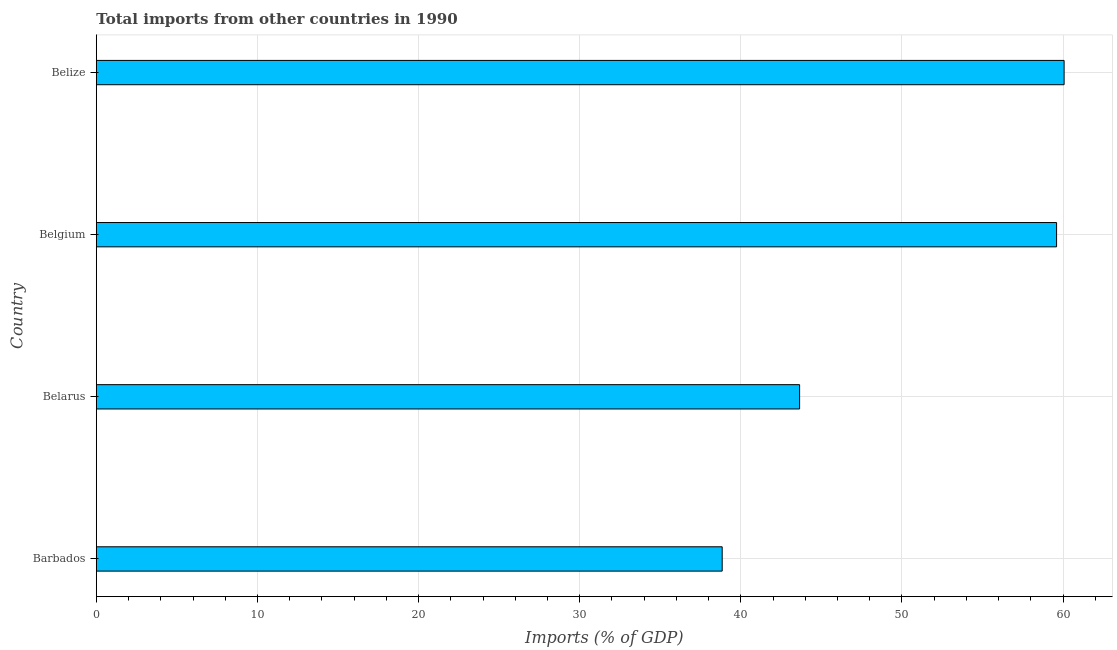Does the graph contain grids?
Give a very brief answer. Yes. What is the title of the graph?
Offer a very short reply. Total imports from other countries in 1990. What is the label or title of the X-axis?
Offer a terse response. Imports (% of GDP). What is the label or title of the Y-axis?
Keep it short and to the point. Country. What is the total imports in Belize?
Give a very brief answer. 60.07. Across all countries, what is the maximum total imports?
Offer a very short reply. 60.07. Across all countries, what is the minimum total imports?
Your answer should be very brief. 38.84. In which country was the total imports maximum?
Provide a succinct answer. Belize. In which country was the total imports minimum?
Make the answer very short. Barbados. What is the sum of the total imports?
Offer a very short reply. 202.16. What is the difference between the total imports in Barbados and Belize?
Give a very brief answer. -21.22. What is the average total imports per country?
Make the answer very short. 50.54. What is the median total imports?
Offer a terse response. 51.62. In how many countries, is the total imports greater than 56 %?
Provide a succinct answer. 2. What is the ratio of the total imports in Belarus to that in Belgium?
Offer a very short reply. 0.73. Is the total imports in Belgium less than that in Belize?
Provide a succinct answer. Yes. Is the difference between the total imports in Barbados and Belarus greater than the difference between any two countries?
Provide a succinct answer. No. What is the difference between the highest and the second highest total imports?
Make the answer very short. 0.47. What is the difference between the highest and the lowest total imports?
Keep it short and to the point. 21.22. In how many countries, is the total imports greater than the average total imports taken over all countries?
Your answer should be compact. 2. How many bars are there?
Keep it short and to the point. 4. Are all the bars in the graph horizontal?
Your response must be concise. Yes. How many countries are there in the graph?
Your answer should be very brief. 4. Are the values on the major ticks of X-axis written in scientific E-notation?
Your answer should be very brief. No. What is the Imports (% of GDP) in Barbados?
Provide a short and direct response. 38.84. What is the Imports (% of GDP) of Belarus?
Your response must be concise. 43.65. What is the Imports (% of GDP) in Belgium?
Your answer should be very brief. 59.6. What is the Imports (% of GDP) of Belize?
Keep it short and to the point. 60.07. What is the difference between the Imports (% of GDP) in Barbados and Belarus?
Offer a terse response. -4.81. What is the difference between the Imports (% of GDP) in Barbados and Belgium?
Keep it short and to the point. -20.75. What is the difference between the Imports (% of GDP) in Barbados and Belize?
Keep it short and to the point. -21.22. What is the difference between the Imports (% of GDP) in Belarus and Belgium?
Provide a short and direct response. -15.95. What is the difference between the Imports (% of GDP) in Belarus and Belize?
Offer a terse response. -16.42. What is the difference between the Imports (% of GDP) in Belgium and Belize?
Your answer should be compact. -0.47. What is the ratio of the Imports (% of GDP) in Barbados to that in Belarus?
Offer a very short reply. 0.89. What is the ratio of the Imports (% of GDP) in Barbados to that in Belgium?
Your response must be concise. 0.65. What is the ratio of the Imports (% of GDP) in Barbados to that in Belize?
Offer a terse response. 0.65. What is the ratio of the Imports (% of GDP) in Belarus to that in Belgium?
Keep it short and to the point. 0.73. What is the ratio of the Imports (% of GDP) in Belarus to that in Belize?
Your answer should be very brief. 0.73. 